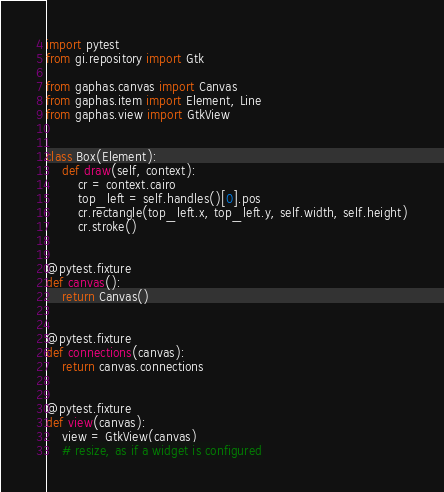<code> <loc_0><loc_0><loc_500><loc_500><_Python_>import pytest
from gi.repository import Gtk

from gaphas.canvas import Canvas
from gaphas.item import Element, Line
from gaphas.view import GtkView


class Box(Element):
    def draw(self, context):
        cr = context.cairo
        top_left = self.handles()[0].pos
        cr.rectangle(top_left.x, top_left.y, self.width, self.height)
        cr.stroke()


@pytest.fixture
def canvas():
    return Canvas()


@pytest.fixture
def connections(canvas):
    return canvas.connections


@pytest.fixture
def view(canvas):
    view = GtkView(canvas)
    # resize, as if a widget is configured</code> 